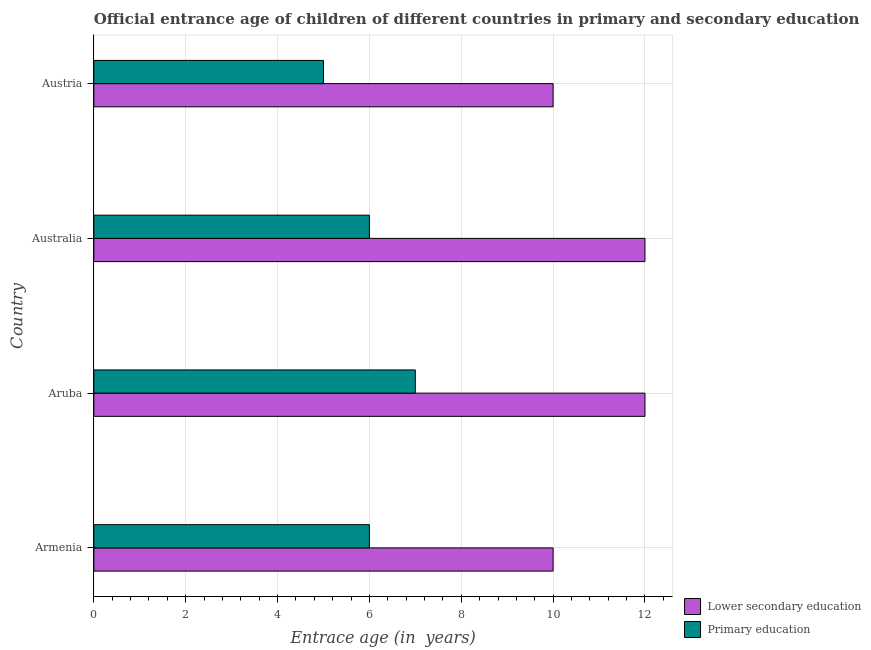How many bars are there on the 3rd tick from the top?
Keep it short and to the point. 2. How many bars are there on the 3rd tick from the bottom?
Your response must be concise. 2. In how many cases, is the number of bars for a given country not equal to the number of legend labels?
Give a very brief answer. 0. What is the entrance age of children in lower secondary education in Aruba?
Offer a very short reply. 12. Across all countries, what is the maximum entrance age of chiildren in primary education?
Make the answer very short. 7. Across all countries, what is the minimum entrance age of children in lower secondary education?
Your response must be concise. 10. In which country was the entrance age of chiildren in primary education maximum?
Your answer should be compact. Aruba. In which country was the entrance age of chiildren in primary education minimum?
Ensure brevity in your answer.  Austria. What is the total entrance age of children in lower secondary education in the graph?
Offer a very short reply. 44. What is the difference between the entrance age of children in lower secondary education in Armenia and the entrance age of chiildren in primary education in Aruba?
Give a very brief answer. 3. What is the average entrance age of children in lower secondary education per country?
Provide a short and direct response. 11. What is the difference between the entrance age of children in lower secondary education and entrance age of chiildren in primary education in Armenia?
Offer a very short reply. 4. In how many countries, is the entrance age of chiildren in primary education greater than 9.2 years?
Make the answer very short. 0. What is the ratio of the entrance age of children in lower secondary education in Australia to that in Austria?
Provide a short and direct response. 1.2. Is the entrance age of children in lower secondary education in Aruba less than that in Austria?
Give a very brief answer. No. What is the difference between the highest and the lowest entrance age of children in lower secondary education?
Keep it short and to the point. 2. In how many countries, is the entrance age of chiildren in primary education greater than the average entrance age of chiildren in primary education taken over all countries?
Keep it short and to the point. 1. What does the 1st bar from the top in Austria represents?
Provide a short and direct response. Primary education. What does the 2nd bar from the bottom in Austria represents?
Your answer should be very brief. Primary education. How many bars are there?
Your response must be concise. 8. Does the graph contain any zero values?
Offer a terse response. No. How many legend labels are there?
Provide a succinct answer. 2. How are the legend labels stacked?
Make the answer very short. Vertical. What is the title of the graph?
Ensure brevity in your answer.  Official entrance age of children of different countries in primary and secondary education. What is the label or title of the X-axis?
Your answer should be compact. Entrace age (in  years). What is the label or title of the Y-axis?
Your answer should be compact. Country. What is the Entrace age (in  years) of Lower secondary education in Armenia?
Provide a short and direct response. 10. What is the Entrace age (in  years) of Primary education in Armenia?
Provide a succinct answer. 6. What is the Entrace age (in  years) in Lower secondary education in Aruba?
Provide a short and direct response. 12. What is the Entrace age (in  years) in Primary education in Australia?
Offer a very short reply. 6. Across all countries, what is the minimum Entrace age (in  years) in Lower secondary education?
Make the answer very short. 10. Across all countries, what is the minimum Entrace age (in  years) of Primary education?
Ensure brevity in your answer.  5. What is the total Entrace age (in  years) of Primary education in the graph?
Offer a terse response. 24. What is the difference between the Entrace age (in  years) of Primary education in Armenia and that in Aruba?
Make the answer very short. -1. What is the difference between the Entrace age (in  years) in Primary education in Armenia and that in Australia?
Give a very brief answer. 0. What is the difference between the Entrace age (in  years) of Lower secondary education in Armenia and that in Austria?
Your answer should be compact. 0. What is the difference between the Entrace age (in  years) of Lower secondary education in Aruba and that in Australia?
Offer a terse response. 0. What is the difference between the Entrace age (in  years) in Primary education in Aruba and that in Australia?
Offer a very short reply. 1. What is the difference between the Entrace age (in  years) in Lower secondary education in Aruba and that in Austria?
Offer a terse response. 2. What is the difference between the Entrace age (in  years) in Lower secondary education in Australia and that in Austria?
Your answer should be very brief. 2. What is the difference between the Entrace age (in  years) in Primary education in Australia and that in Austria?
Make the answer very short. 1. What is the difference between the Entrace age (in  years) of Lower secondary education in Armenia and the Entrace age (in  years) of Primary education in Australia?
Your response must be concise. 4. What is the difference between the Entrace age (in  years) of Lower secondary education in Aruba and the Entrace age (in  years) of Primary education in Austria?
Provide a succinct answer. 7. What is the difference between the Entrace age (in  years) of Lower secondary education in Australia and the Entrace age (in  years) of Primary education in Austria?
Keep it short and to the point. 7. What is the average Entrace age (in  years) of Primary education per country?
Offer a very short reply. 6. What is the ratio of the Entrace age (in  years) of Primary education in Armenia to that in Australia?
Keep it short and to the point. 1. What is the ratio of the Entrace age (in  years) in Lower secondary education in Armenia to that in Austria?
Offer a terse response. 1. What is the ratio of the Entrace age (in  years) in Lower secondary education in Aruba to that in Australia?
Offer a very short reply. 1. What is the ratio of the Entrace age (in  years) in Primary education in Aruba to that in Austria?
Ensure brevity in your answer.  1.4. What is the difference between the highest and the second highest Entrace age (in  years) of Primary education?
Ensure brevity in your answer.  1. What is the difference between the highest and the lowest Entrace age (in  years) in Primary education?
Offer a very short reply. 2. 